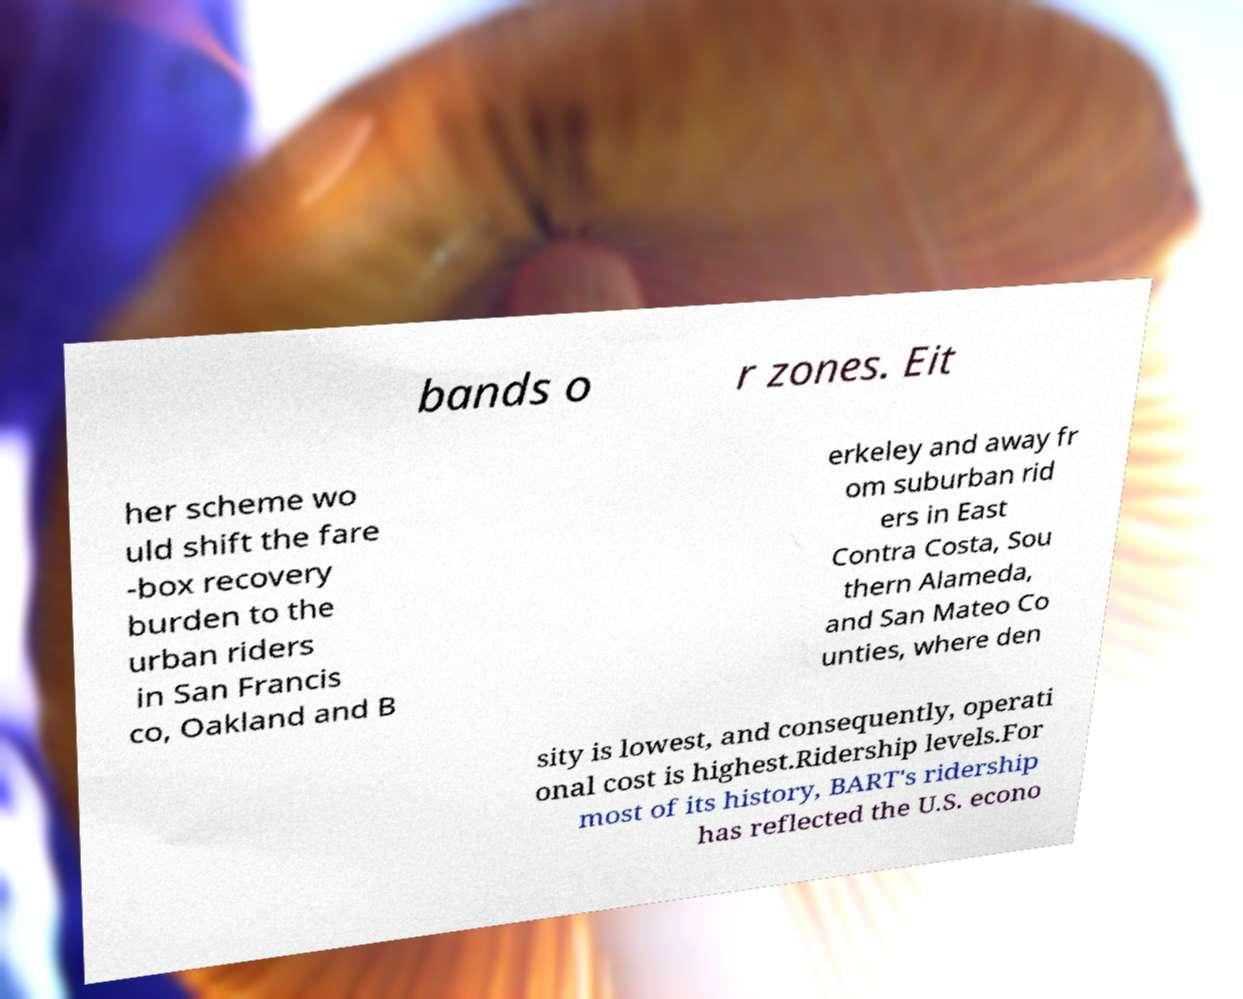Can you read and provide the text displayed in the image?This photo seems to have some interesting text. Can you extract and type it out for me? bands o r zones. Eit her scheme wo uld shift the fare -box recovery burden to the urban riders in San Francis co, Oakland and B erkeley and away fr om suburban rid ers in East Contra Costa, Sou thern Alameda, and San Mateo Co unties, where den sity is lowest, and consequently, operati onal cost is highest.Ridership levels.For most of its history, BART's ridership has reflected the U.S. econo 